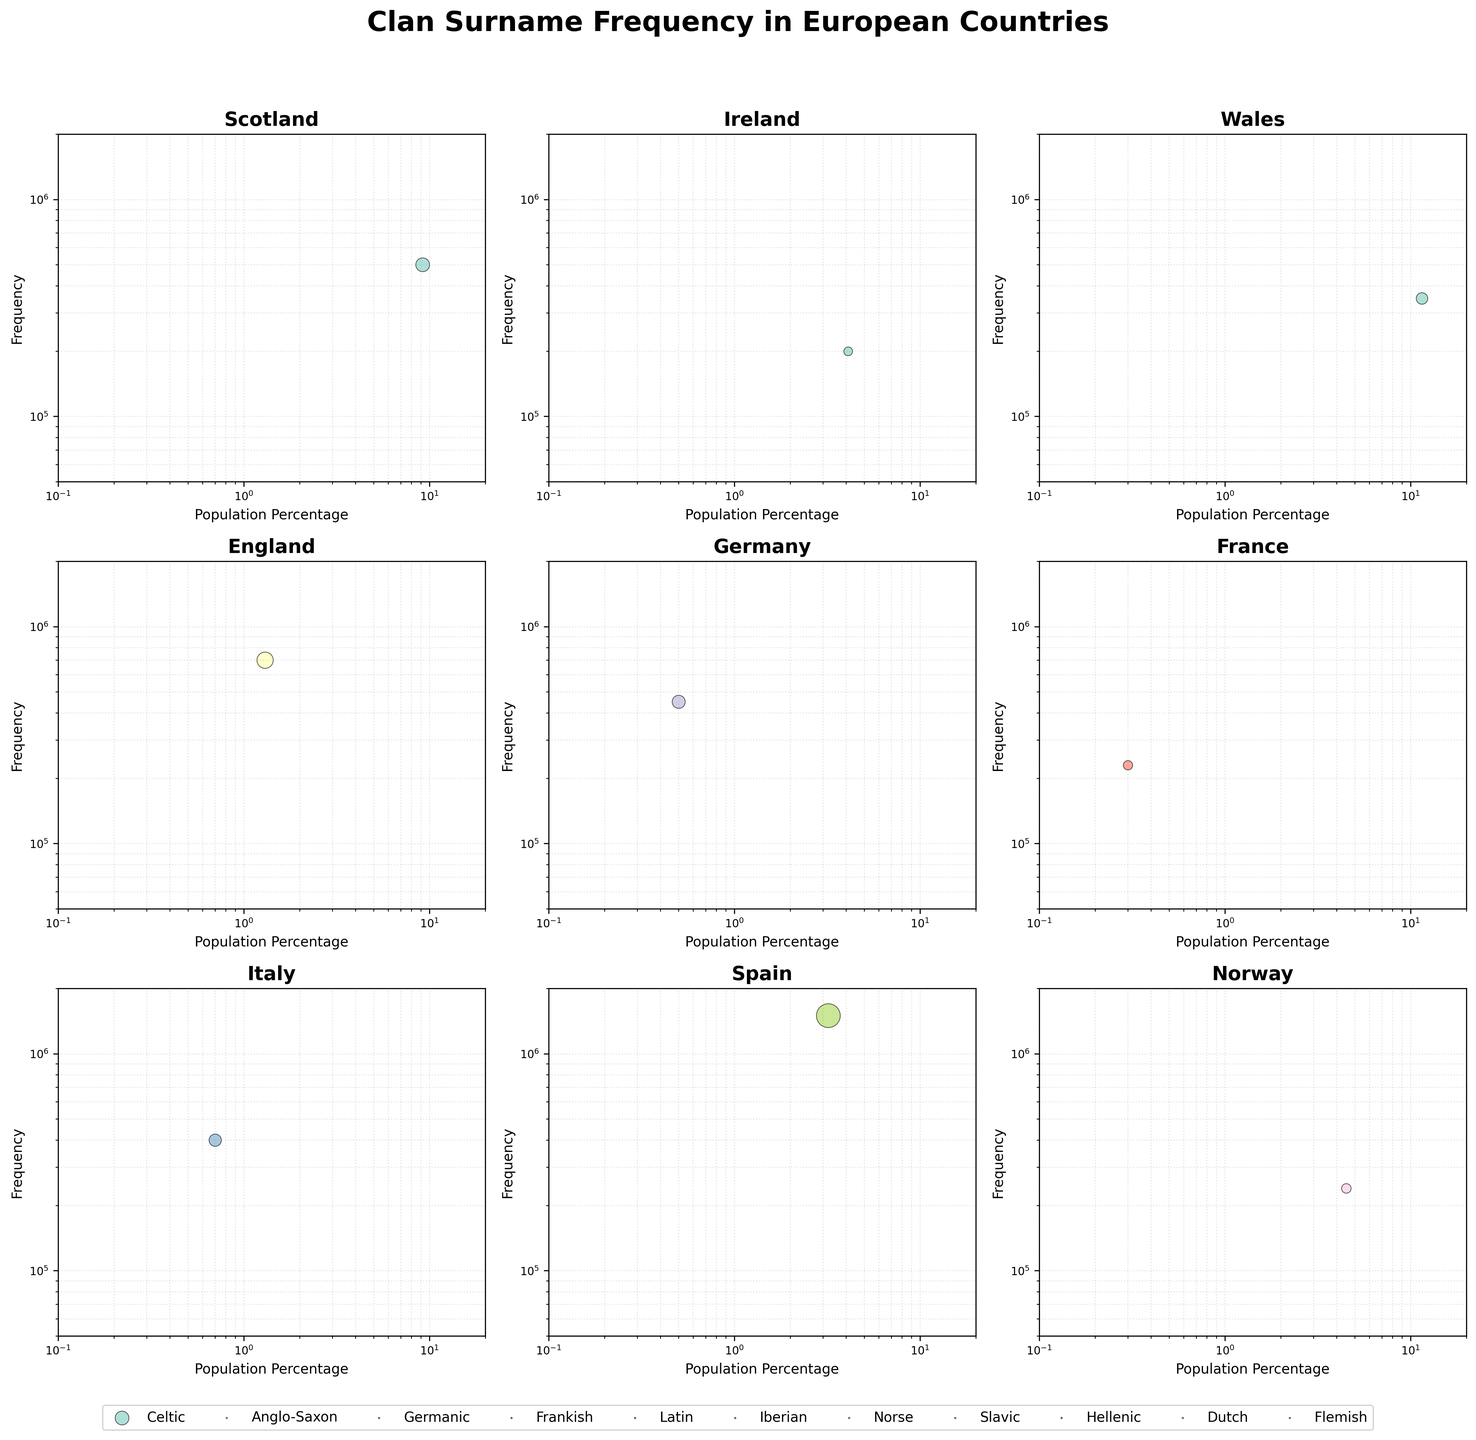What is the title of the figure? The title of the figure is usually placed at the top center of the image. In this figure, the title 'Clan Surname Frequency in European Countries' is positioned prominently in bold and large font, indicating the theme of the subplot of bubble charts.
Answer: Clan Surname Frequency in European Countries How many subplots are included in the figure? By counting the number of visible subplots, in this case arranged in a 3x3 grid, you identify that each subplot represents a different country. The total number of countries or subplots can be counted by observing the figure.
Answer: 9 Which country has the highest surname frequency represented in the subplots? By observing the y-axis labeled 'Frequency' and identifying the highest data point in each subplot, you can confirm that Spain has the highest surname frequency of 1,500,000 for the surname 'García'.
Answer: Spain In which subplot does the surname frequency and population percentage have a larger range, like covering more area in the chart space? By examining each subplot's data distribution visually and noting the variance in 'Population Percentage' (x-axis) and 'Frequency' (y-axis), you can notice that Wales, with 'Jones,' shows a broad range in these variables, covering a larger area in its subplot.
Answer: Wales Compare the surname frequencies of 'Smith' in England and 'Schmidt' in Germany. Which one is higher? Observing the y-axes for the subplots for England and Germany and noting the specific data points, you see 'Smith' in England has a higher frequency (700,000) compared to 'Schmidt' in Germany (450,000).
Answer: Smith Which country's subplot shows a bubble for Norse origin surnames with higher population percentage? To find Norse origin surnames, you need to identify the color associated with Norse in the legend and compare the 'Population Percentage' of matching bubbles in relevant subplots such as Norway or Sweden. Norway displays a higher population percentage for 'Hansen'.
Answer: Norway Is there a subplot where two historical origins show similar surname frequencies? If so, provide an example. By comparing bubbles' sizes (representing frequency) across all subplots, you can find close matches. For instance, in Sweden, Norse 'Andersson' and another origin could have similar frequencies. However, without seeing an exact similar match, validate with another subplot.
Answer: No exact similarity identified without precise values Which historical origin has the most diverse representation across different subplots? By checking the legend to see all historical origins and scanning for their presence across all different countries' subplots, determine the Celtic origin (seen in Scotland, Ireland, and Wales) has strong representation.
Answer: Celtic 